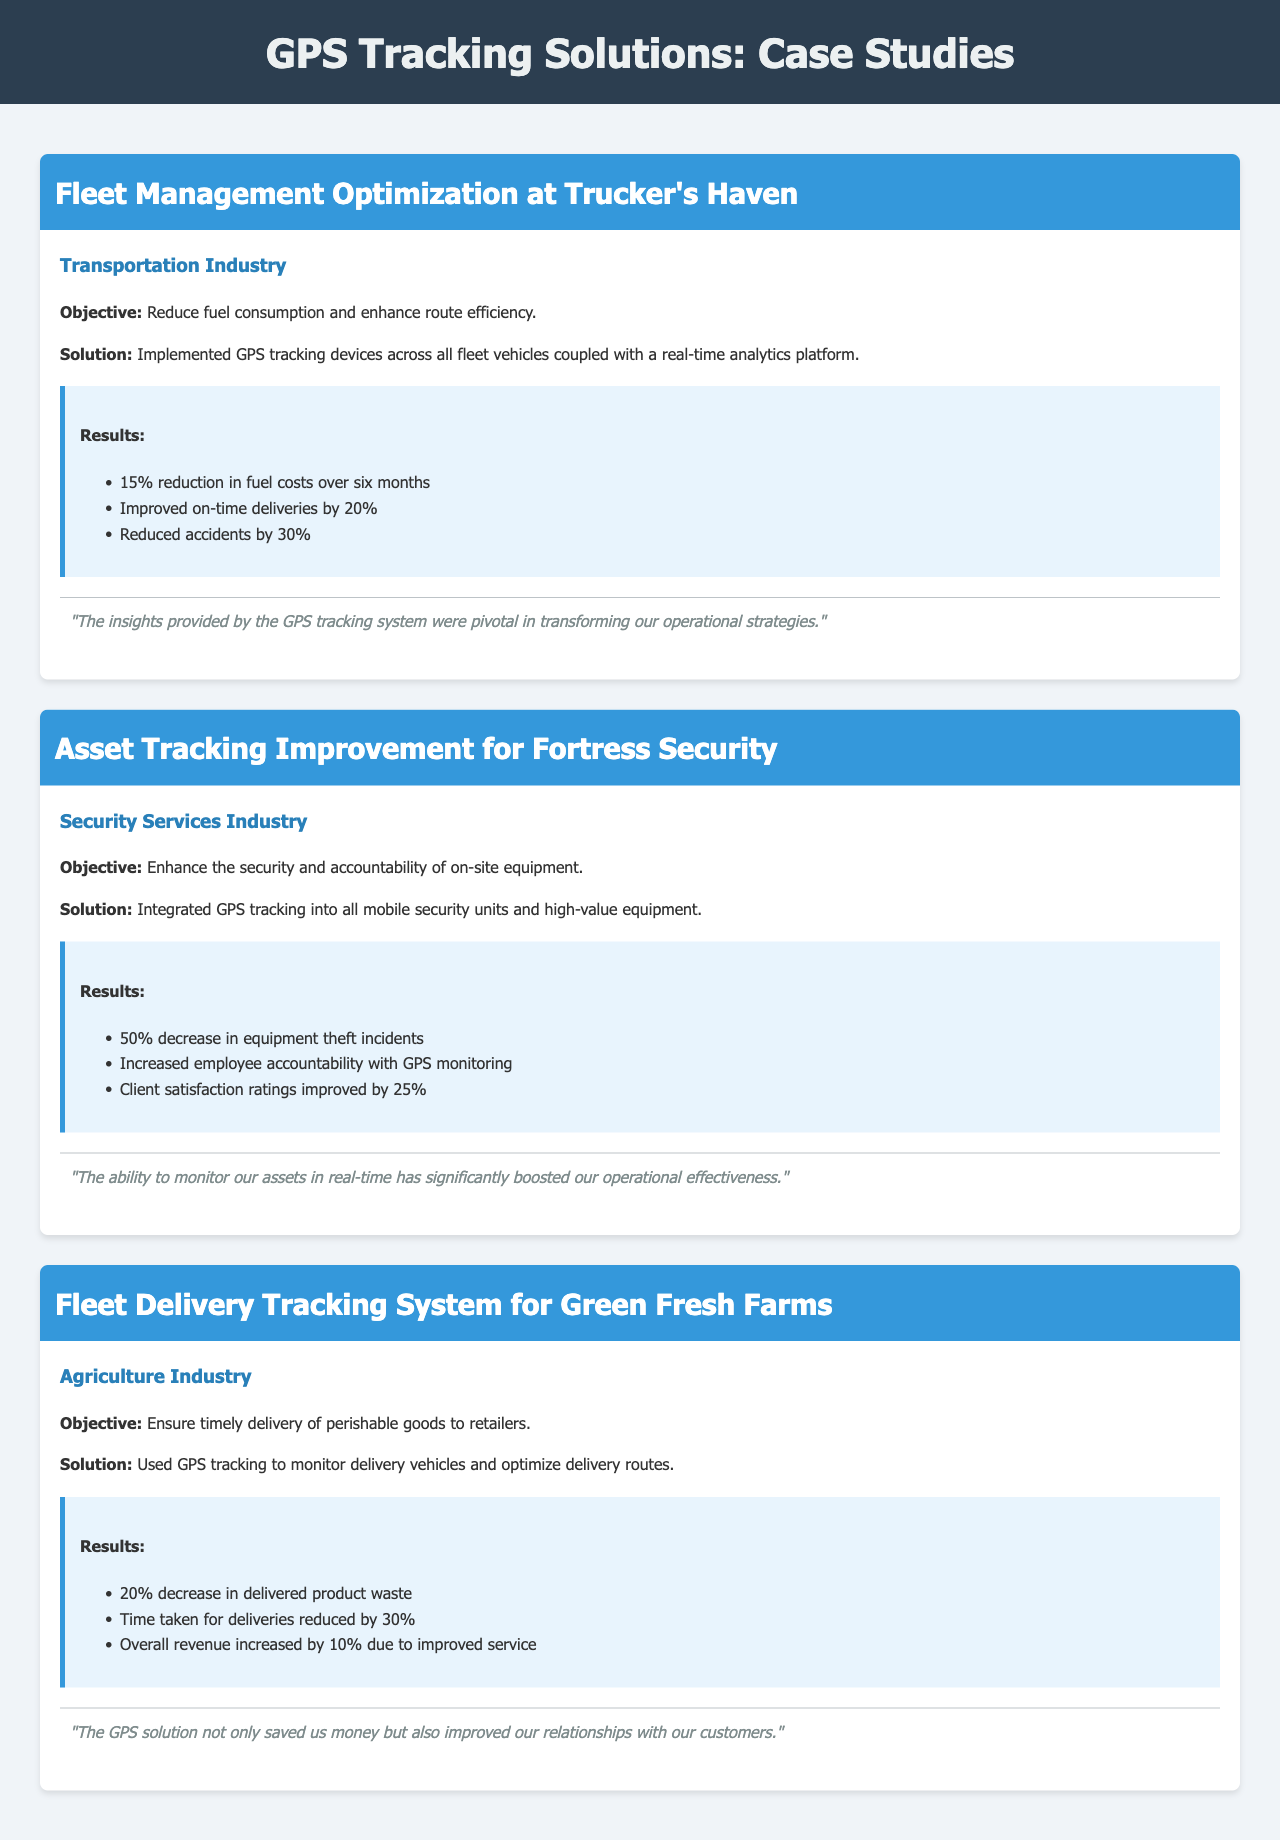What was the objective of Trucker's Haven's case study? The objective was to reduce fuel consumption and enhance route efficiency.
Answer: Reduce fuel consumption and enhance route efficiency How much did fuel costs reduce at Trucker's Haven? The document states a 15% reduction in fuel costs over six months.
Answer: 15% What industry does Fortress Security belong to? According to the case study header, Fortress Security is in the Security Services Industry.
Answer: Security Services Industry What percentage did Fortress Security improve client satisfaction ratings? The results indicate a 25% improvement in client satisfaction ratings.
Answer: 25% What solution was used by Green Fresh Farms to monitor deliveries? They used GPS tracking to monitor delivery vehicles.
Answer: GPS tracking What was the decrease in delivered product waste for Green Fresh Farms? The document mentions a 20% decrease in delivered product waste.
Answer: 20% How many incidents of equipment theft did Fortress Security reduce? The results show a 50% decrease in equipment theft incidents.
Answer: 50% What overall revenue increase did Green Fresh Farms achieve? The results state an overall revenue increased by 10% due to improved service.
Answer: 10% 